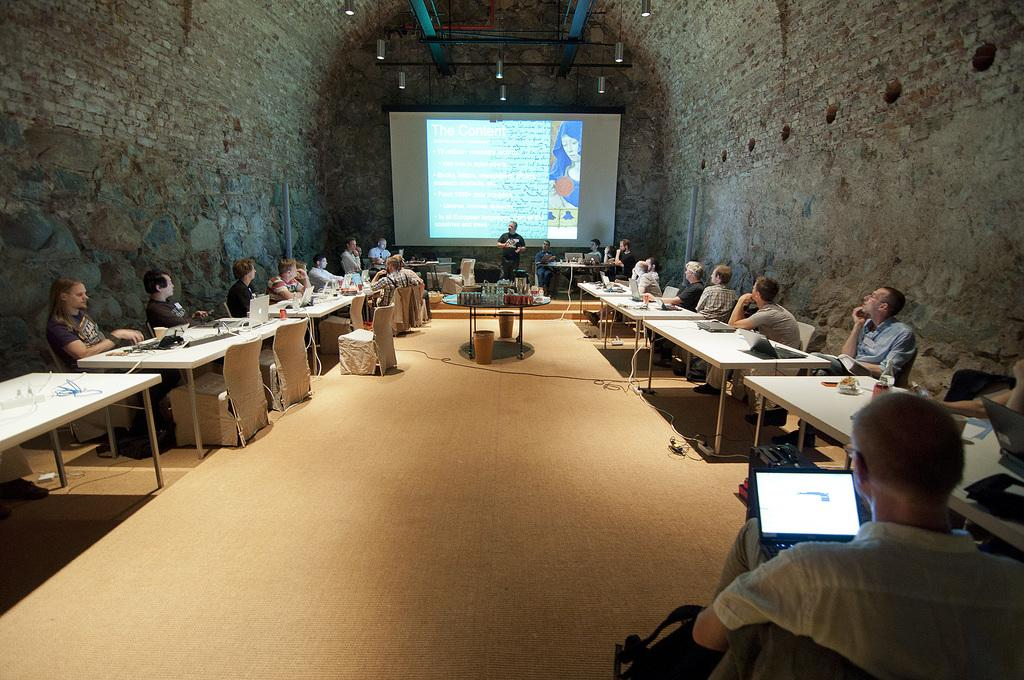What is happening in the image involving the group of people? The people are seated on chairs, and a man is standing and speaking. What objects can be seen on the table in the image? There are laptops on a table in the image. What is the purpose of the projector screen in the image? The projector screen is likely used for displaying information or presentations during the gathering. Where is the kettle located in the image? There is no kettle present in the image. What type of paper is being used by the people in the image? There is no paper visible in the image; the people are using laptops instead. 